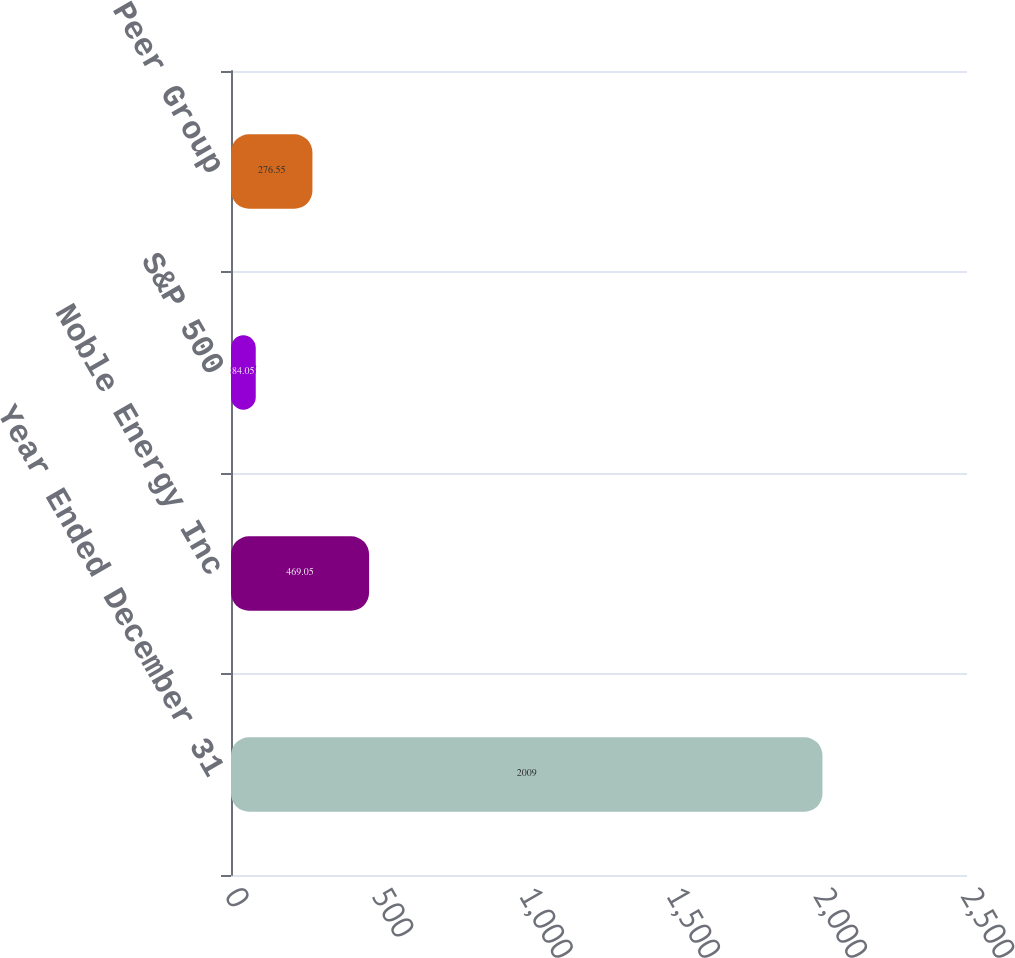<chart> <loc_0><loc_0><loc_500><loc_500><bar_chart><fcel>Year Ended December 31<fcel>Noble Energy Inc<fcel>S&P 500<fcel>Peer Group<nl><fcel>2009<fcel>469.05<fcel>84.05<fcel>276.55<nl></chart> 